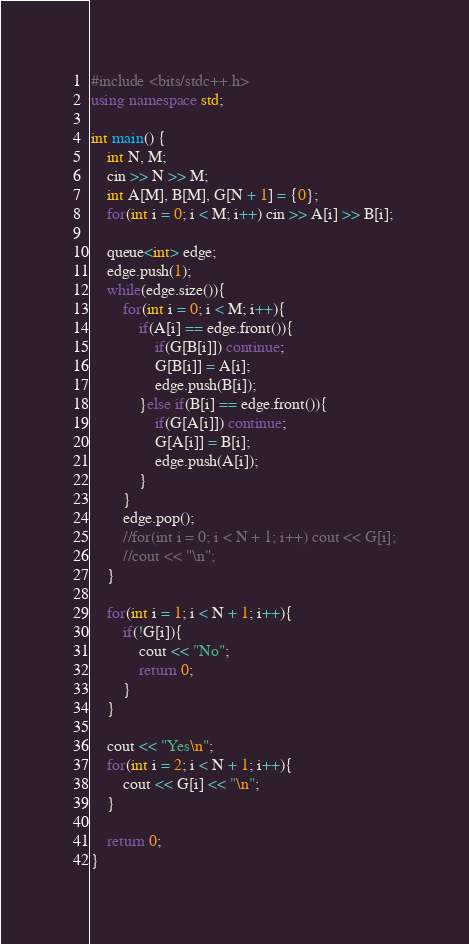Convert code to text. <code><loc_0><loc_0><loc_500><loc_500><_C++_>#include <bits/stdc++.h>
using namespace std;
 
int main() {
  	int N, M;
    cin >> N >> M;
    int A[M], B[M], G[N + 1] = {0};
    for(int i = 0; i < M; i++) cin >> A[i] >> B[i];
  
    queue<int> edge;
    edge.push(1);
    while(edge.size()){
    	for(int i = 0; i < M; i++){
        	if(A[i] == edge.front()){
            	if(G[B[i]]) continue;
                G[B[i]] = A[i];
                edge.push(B[i]);
            }else if(B[i] == edge.front()){
            	if(G[A[i]]) continue;
                G[A[i]] = B[i];
                edge.push(A[i]);
            }
        }
        edge.pop();
        //for(int i = 0; i < N + 1; i++) cout << G[i];
        //cout << "\n";
    }
    
    for(int i = 1; i < N + 1; i++){
     	if(!G[i]){
        	cout << "No";
        	return 0;
        }
    }
  
    cout << "Yes\n";
    for(int i = 2; i < N + 1; i++){
     	cout << G[i] << "\n";
    }

    return 0;
}
</code> 